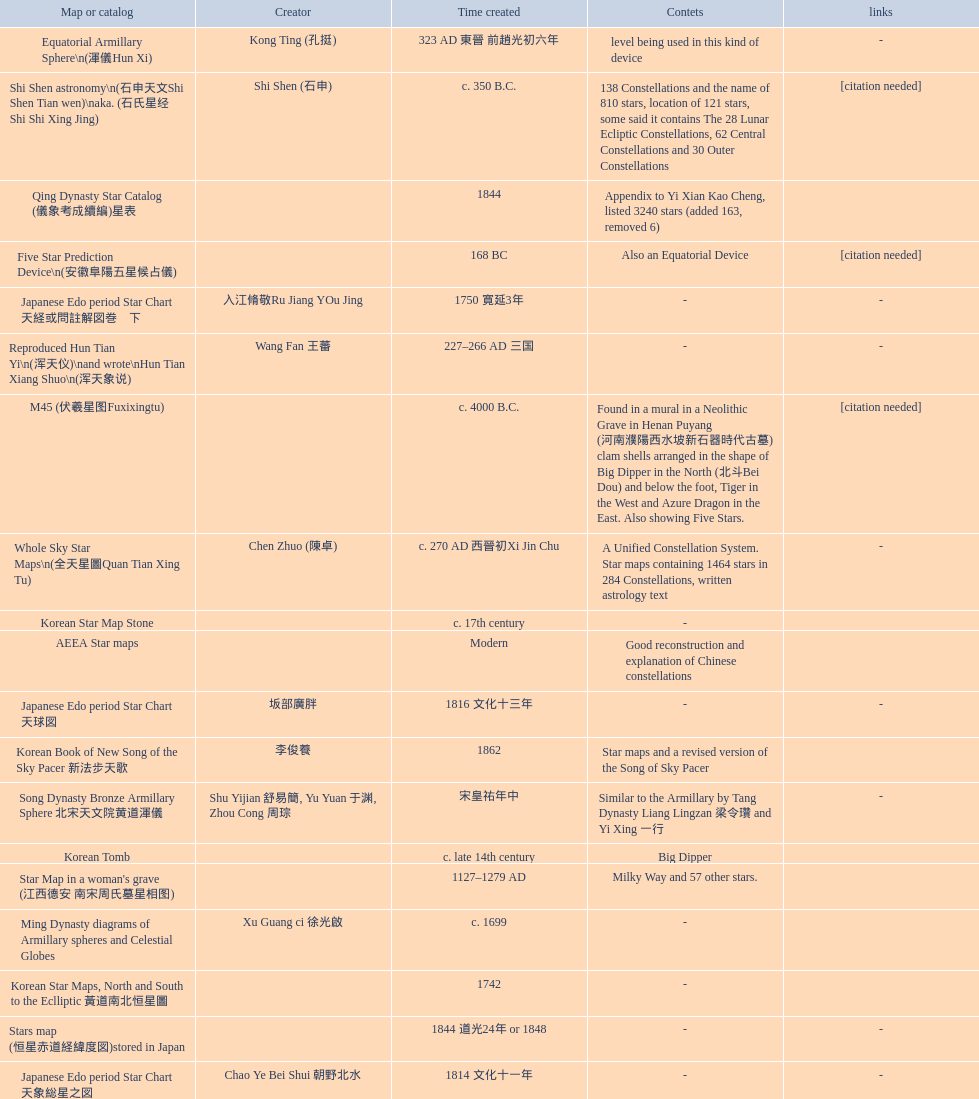When was the first map or catalog created? C. 4000 b.c. 